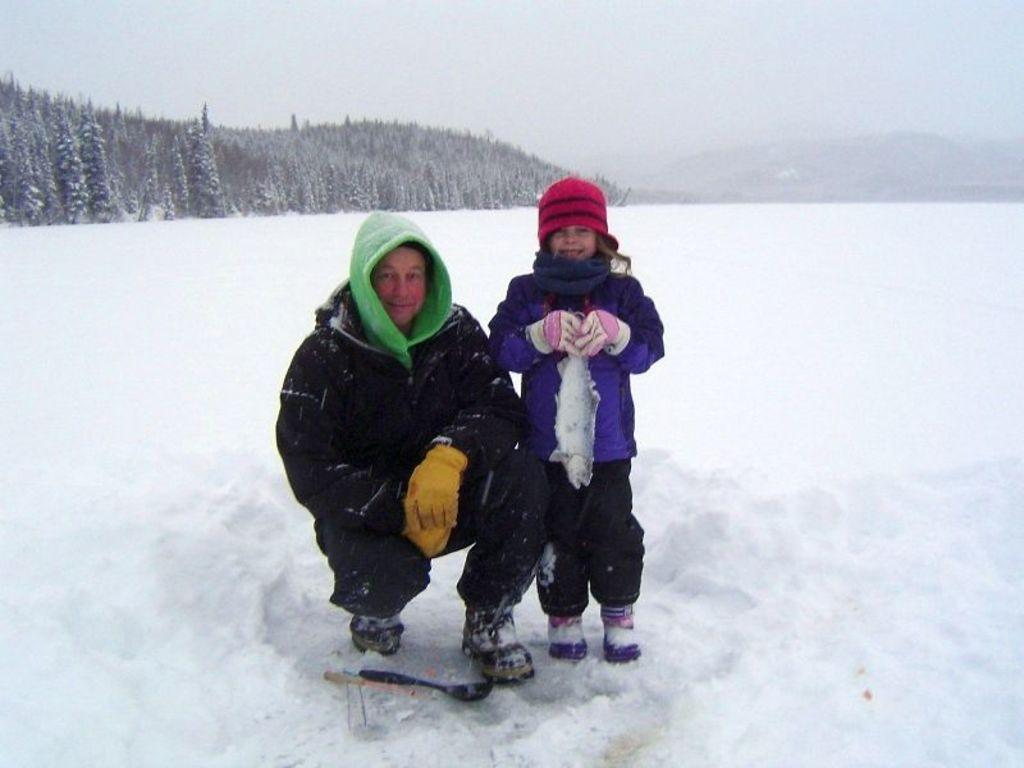How many people are present in the image? There are two people in the image. What is the weather like in the image? There is snow in the image, indicating a cold and wintry environment. What can be seen in the background of the image? There are trees, hills, and the sky visible in the background of the image. What word is being used to communicate between the two people in the image? There is no indication of any verbal communication in the image, so it is impossible to determine what word might be used. --- 